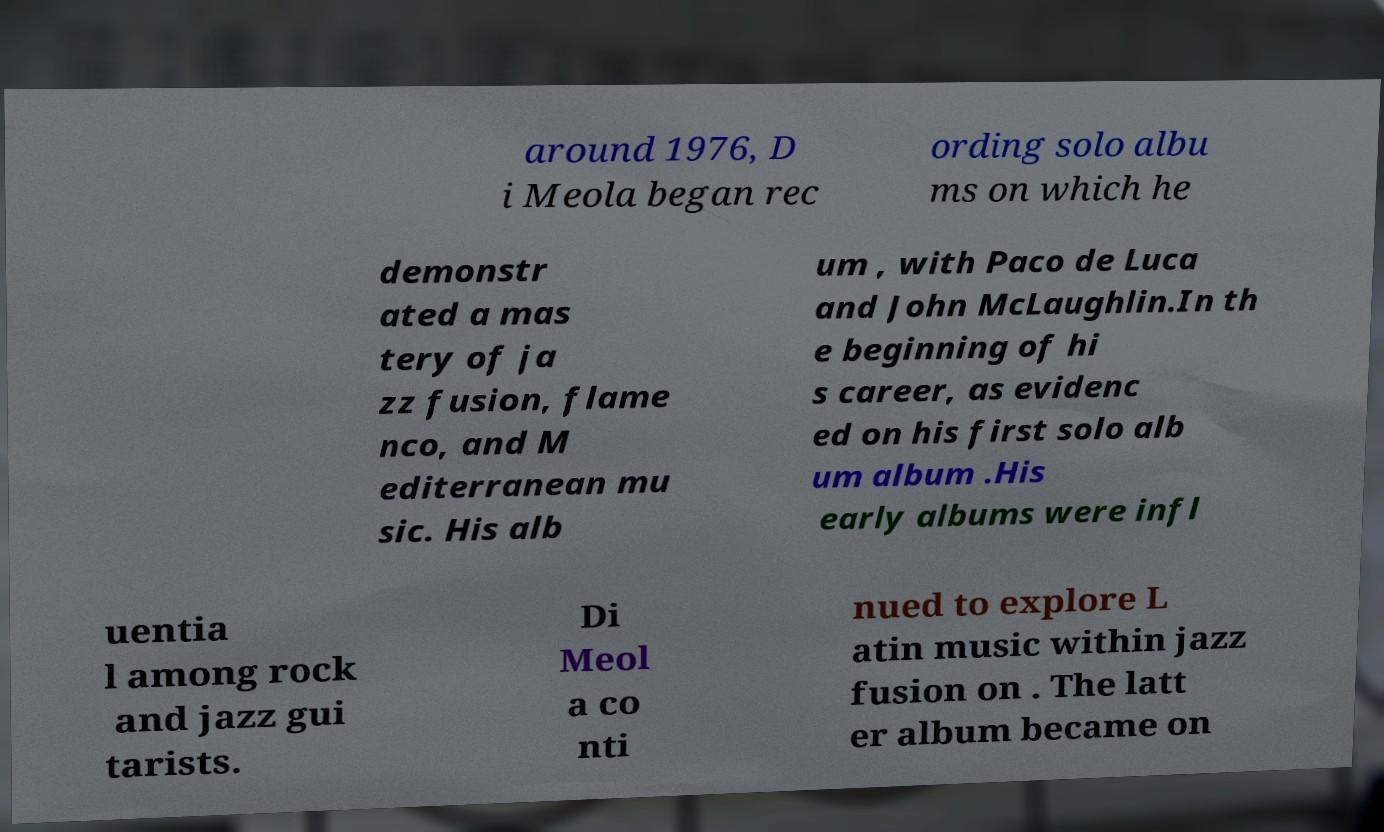What messages or text are displayed in this image? I need them in a readable, typed format. around 1976, D i Meola began rec ording solo albu ms on which he demonstr ated a mas tery of ja zz fusion, flame nco, and M editerranean mu sic. His alb um , with Paco de Luca and John McLaughlin.In th e beginning of hi s career, as evidenc ed on his first solo alb um album .His early albums were infl uentia l among rock and jazz gui tarists. Di Meol a co nti nued to explore L atin music within jazz fusion on . The latt er album became on 